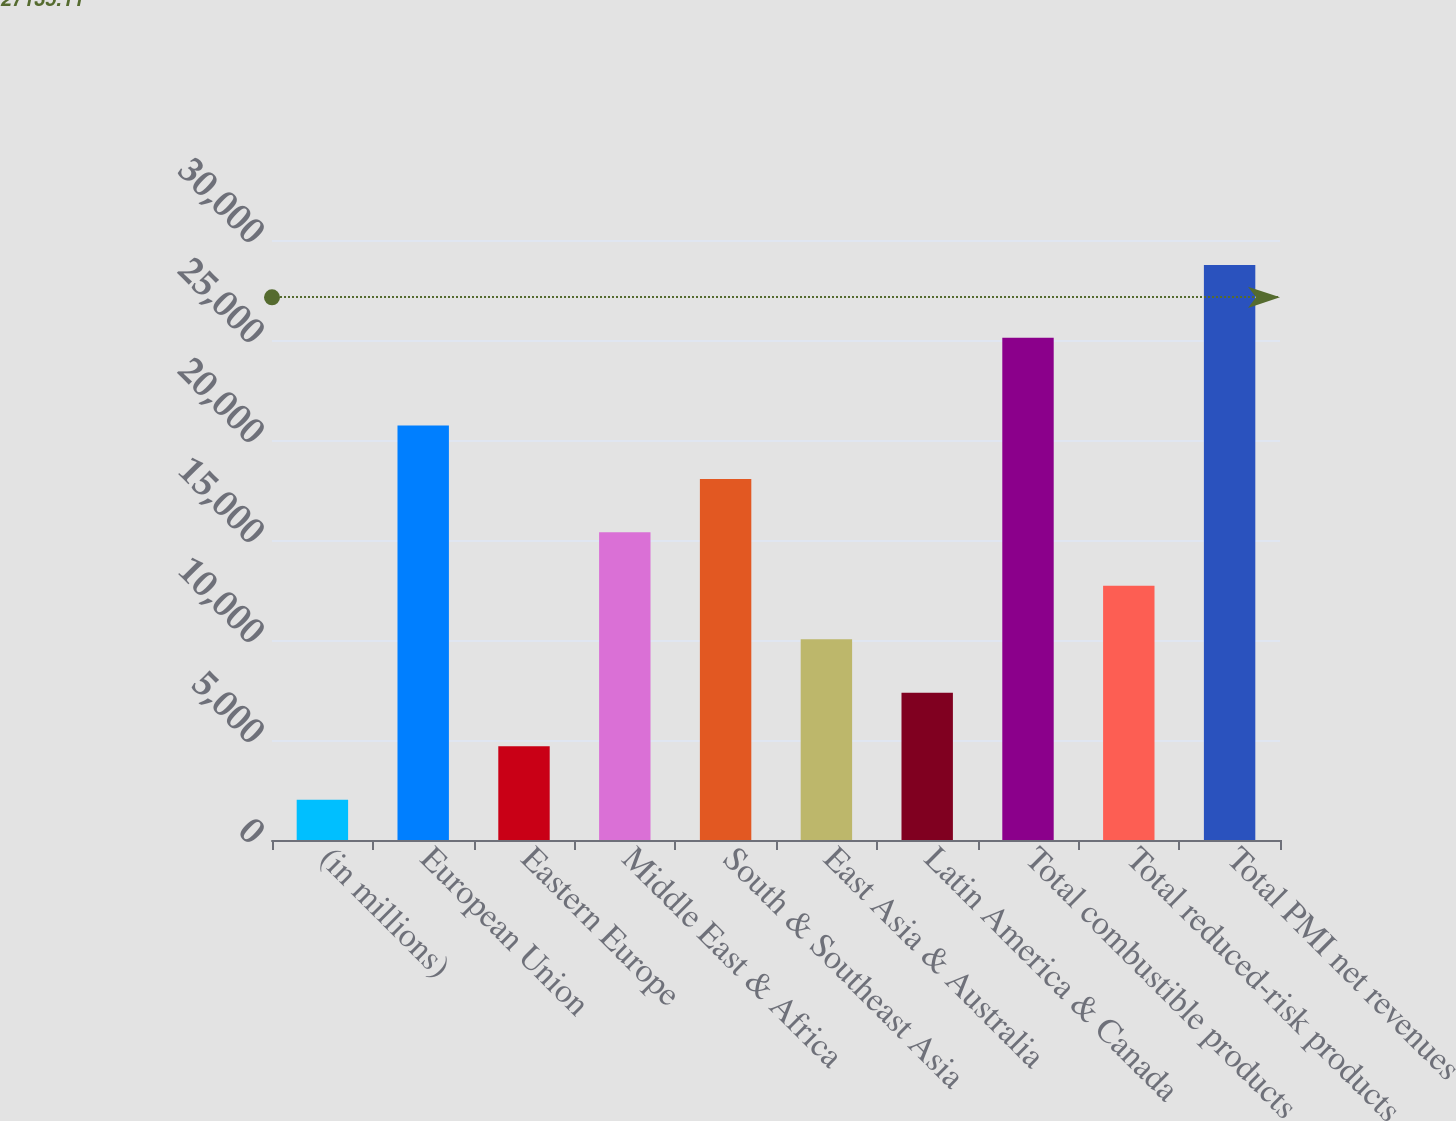<chart> <loc_0><loc_0><loc_500><loc_500><bar_chart><fcel>(in millions)<fcel>European Union<fcel>Eastern Europe<fcel>Middle East & Africa<fcel>South & Southeast Asia<fcel>East Asia & Australia<fcel>Latin America & Canada<fcel>Total combustible products<fcel>Total reduced-risk products<fcel>Total PMI net revenues<nl><fcel>2017<fcel>20728.7<fcel>4690.1<fcel>15382.5<fcel>18055.6<fcel>10036.3<fcel>7363.2<fcel>25107<fcel>12709.4<fcel>28748<nl></chart> 